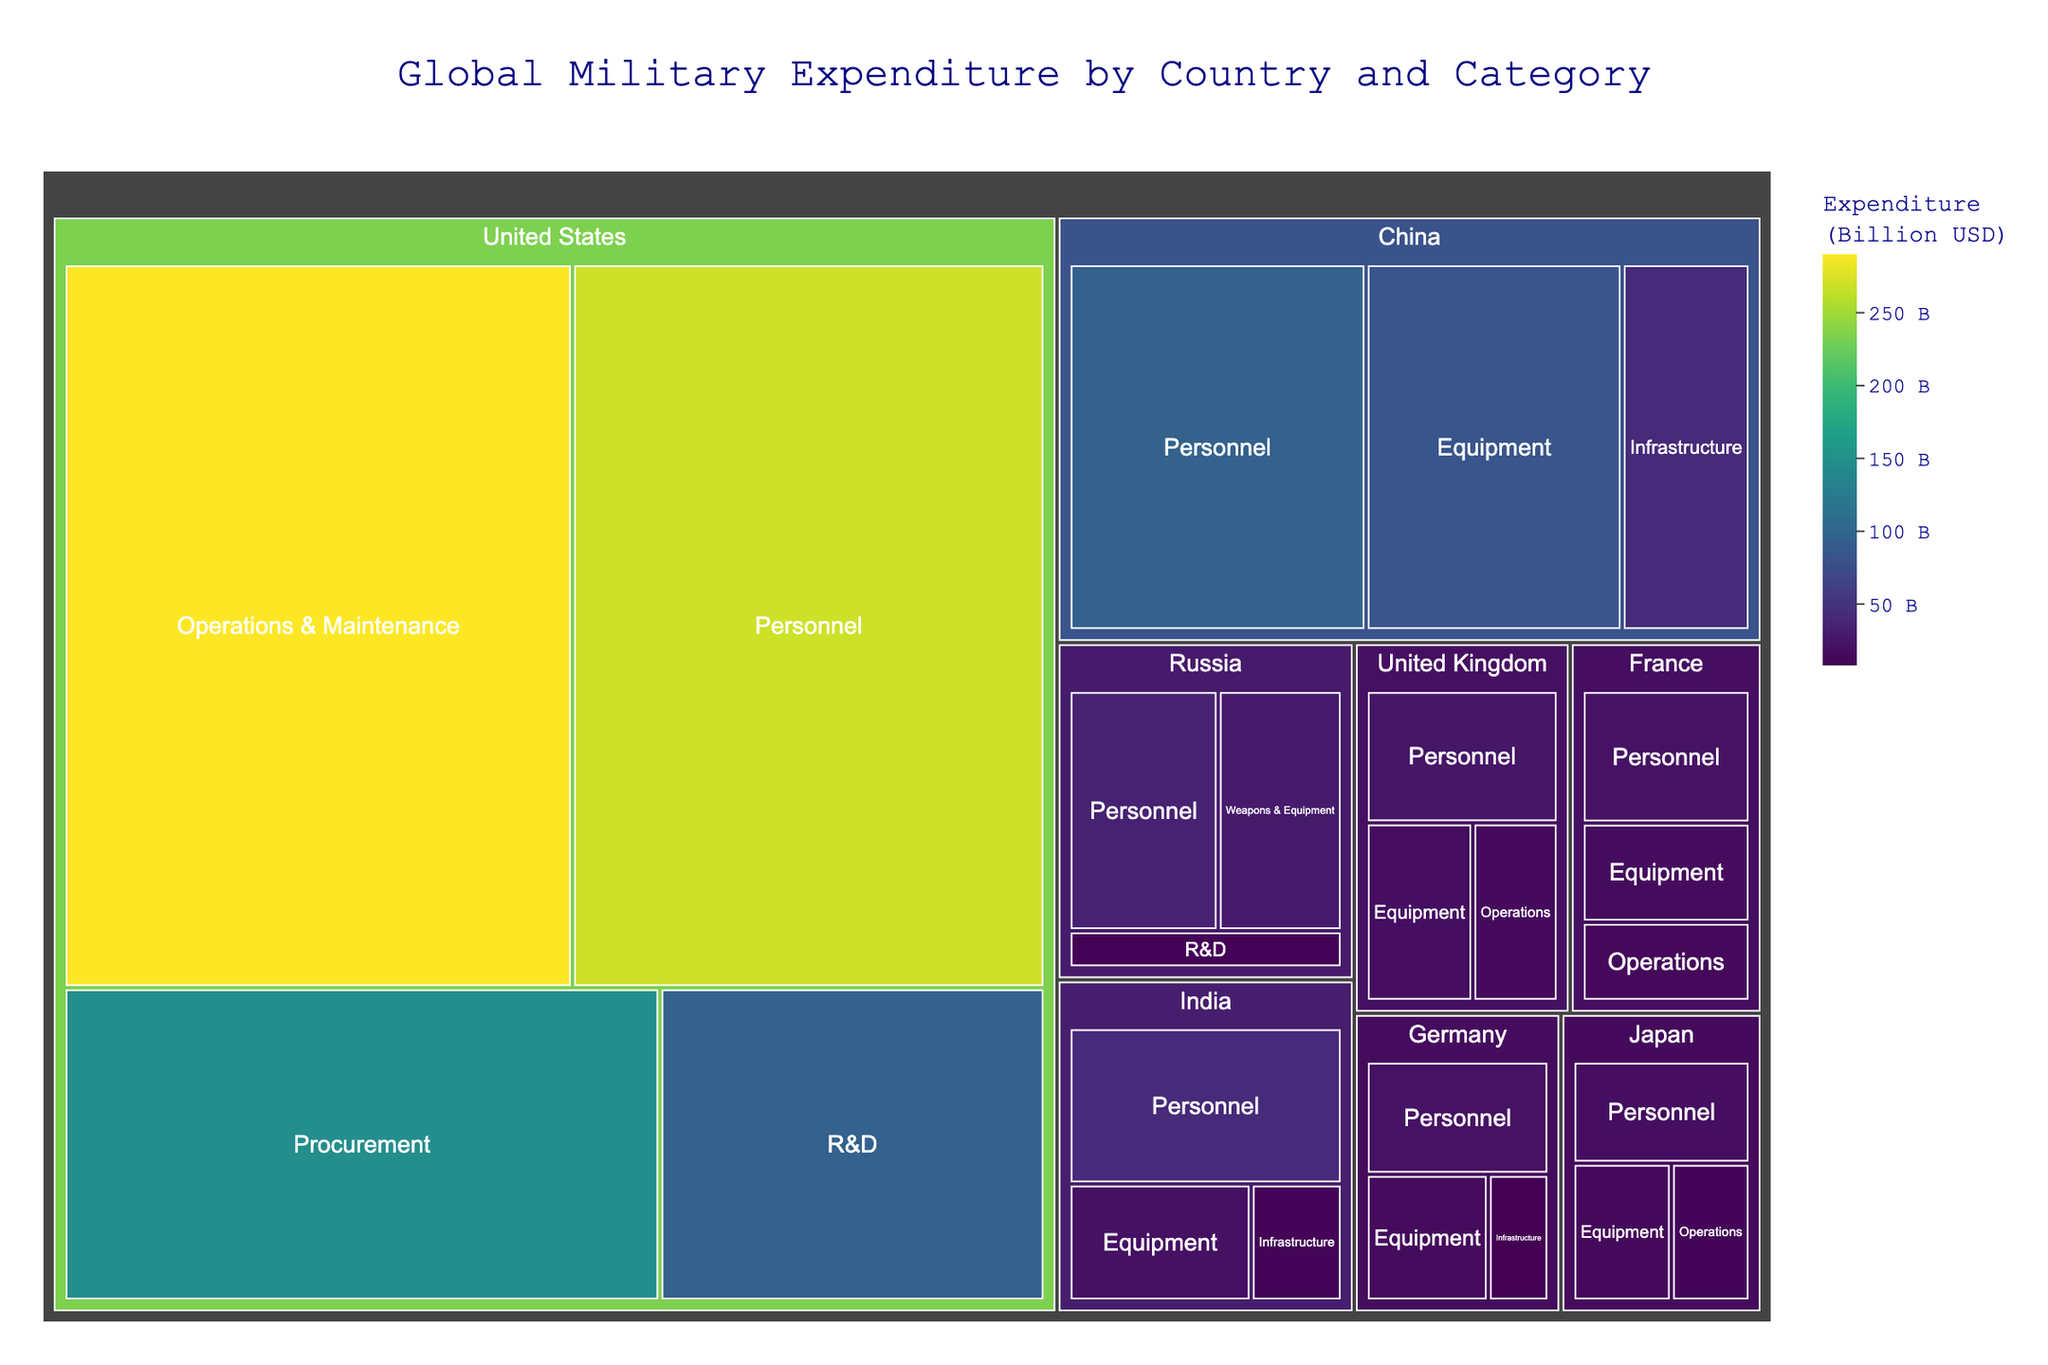What is the title of the figure? The title can be found at the top of the figure.
Answer: Global Military Expenditure by Country and Category Which country has the highest total military expenditure? Look for the largest section in the Treemap. The largest block represents the country with the highest expenditure.
Answer: United States How much does China spend on Personnel compared to the United States? Locate the blocks for Personnel under China and the United States, and compare the expenditure values.
Answer: China: 95.6 Billion USD, United States: 270.0 Billion USD What category does Russia spend the most on? Identify the largest block under Russia. The label within the block will indicate the category.
Answer: Personnel Which country spends the most on Operations & Maintenance? Find the largest block labeled Operations & Maintenance in the entire Treemap.
Answer: United States How much is the total military expenditure of India? Sum up the expenditure values of all categories within India. (41.2 + 20.6 + 10.3)
Answer: 72.1 Billion USD Which two countries have the smallest difference in their military expenditure for Equipment? Compare the Equipment expenditures for all countries and identify the two with the smallest difference. Germany: 15.9 Billion USD, United Kingdom: 18.6 Billion USD. The difference is 2.7 Billion USD.
Answer: Germany and United Kingdom What is the combined military expenditure on R&D by the United States and Russia? Add the R&D expenditure values of the United States and Russia. (95.2 + 9.8)
Answer: 105 Billion USD Which country spends the least on Infrastructure? Identify the smallest block labeled Infrastructure in the entire Treemap.
Answer: Germany How does Japan's total military expenditure compare to France's? Sum the expenditures of all categories within Japan and France, then compare the totals. Japan: 43.9 Billion USD (18.7 + 14.0 + 11.2), France: 51.8 Billion USD (22.1 + 16.5 + 13.2)
Answer: Japan spends less than France 